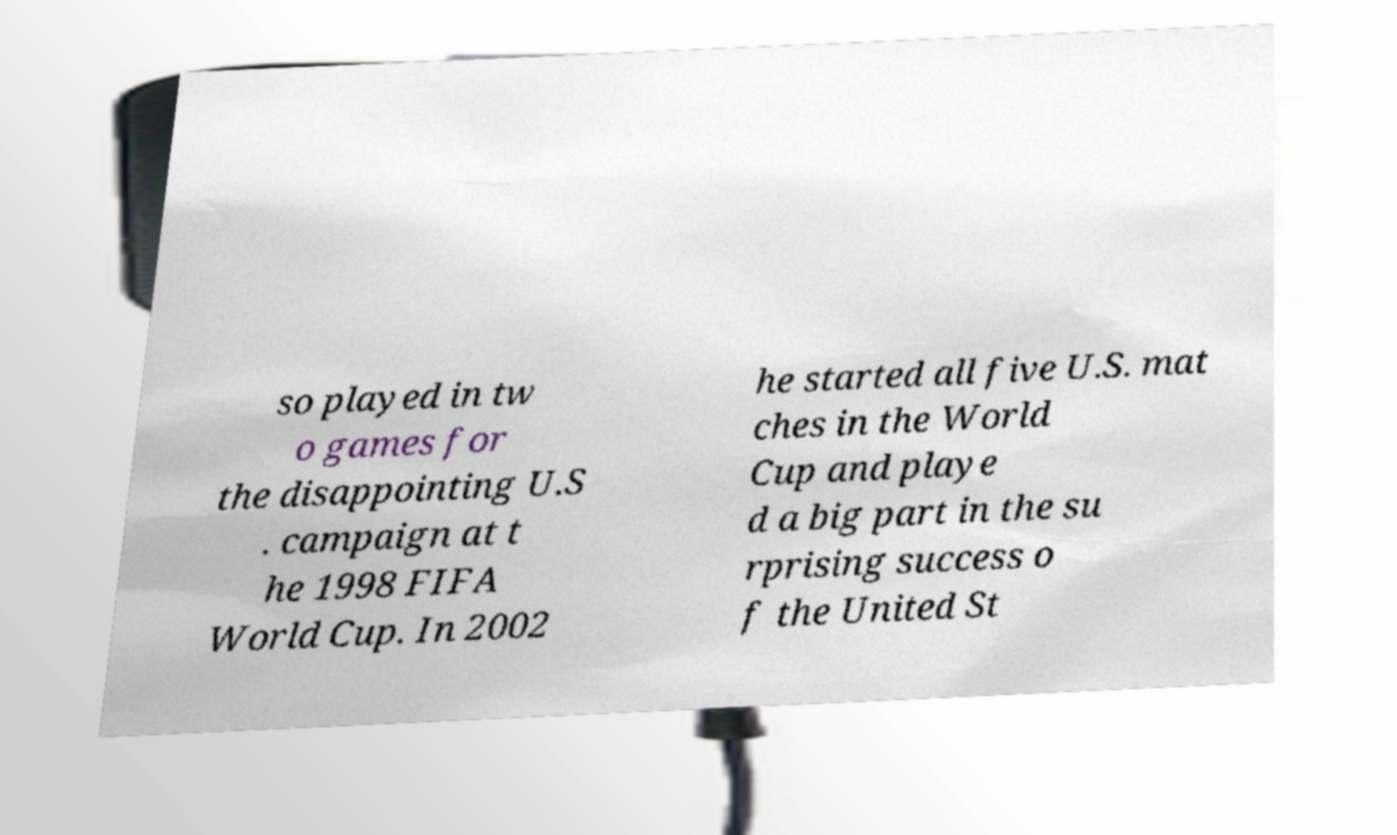Could you assist in decoding the text presented in this image and type it out clearly? so played in tw o games for the disappointing U.S . campaign at t he 1998 FIFA World Cup. In 2002 he started all five U.S. mat ches in the World Cup and playe d a big part in the su rprising success o f the United St 